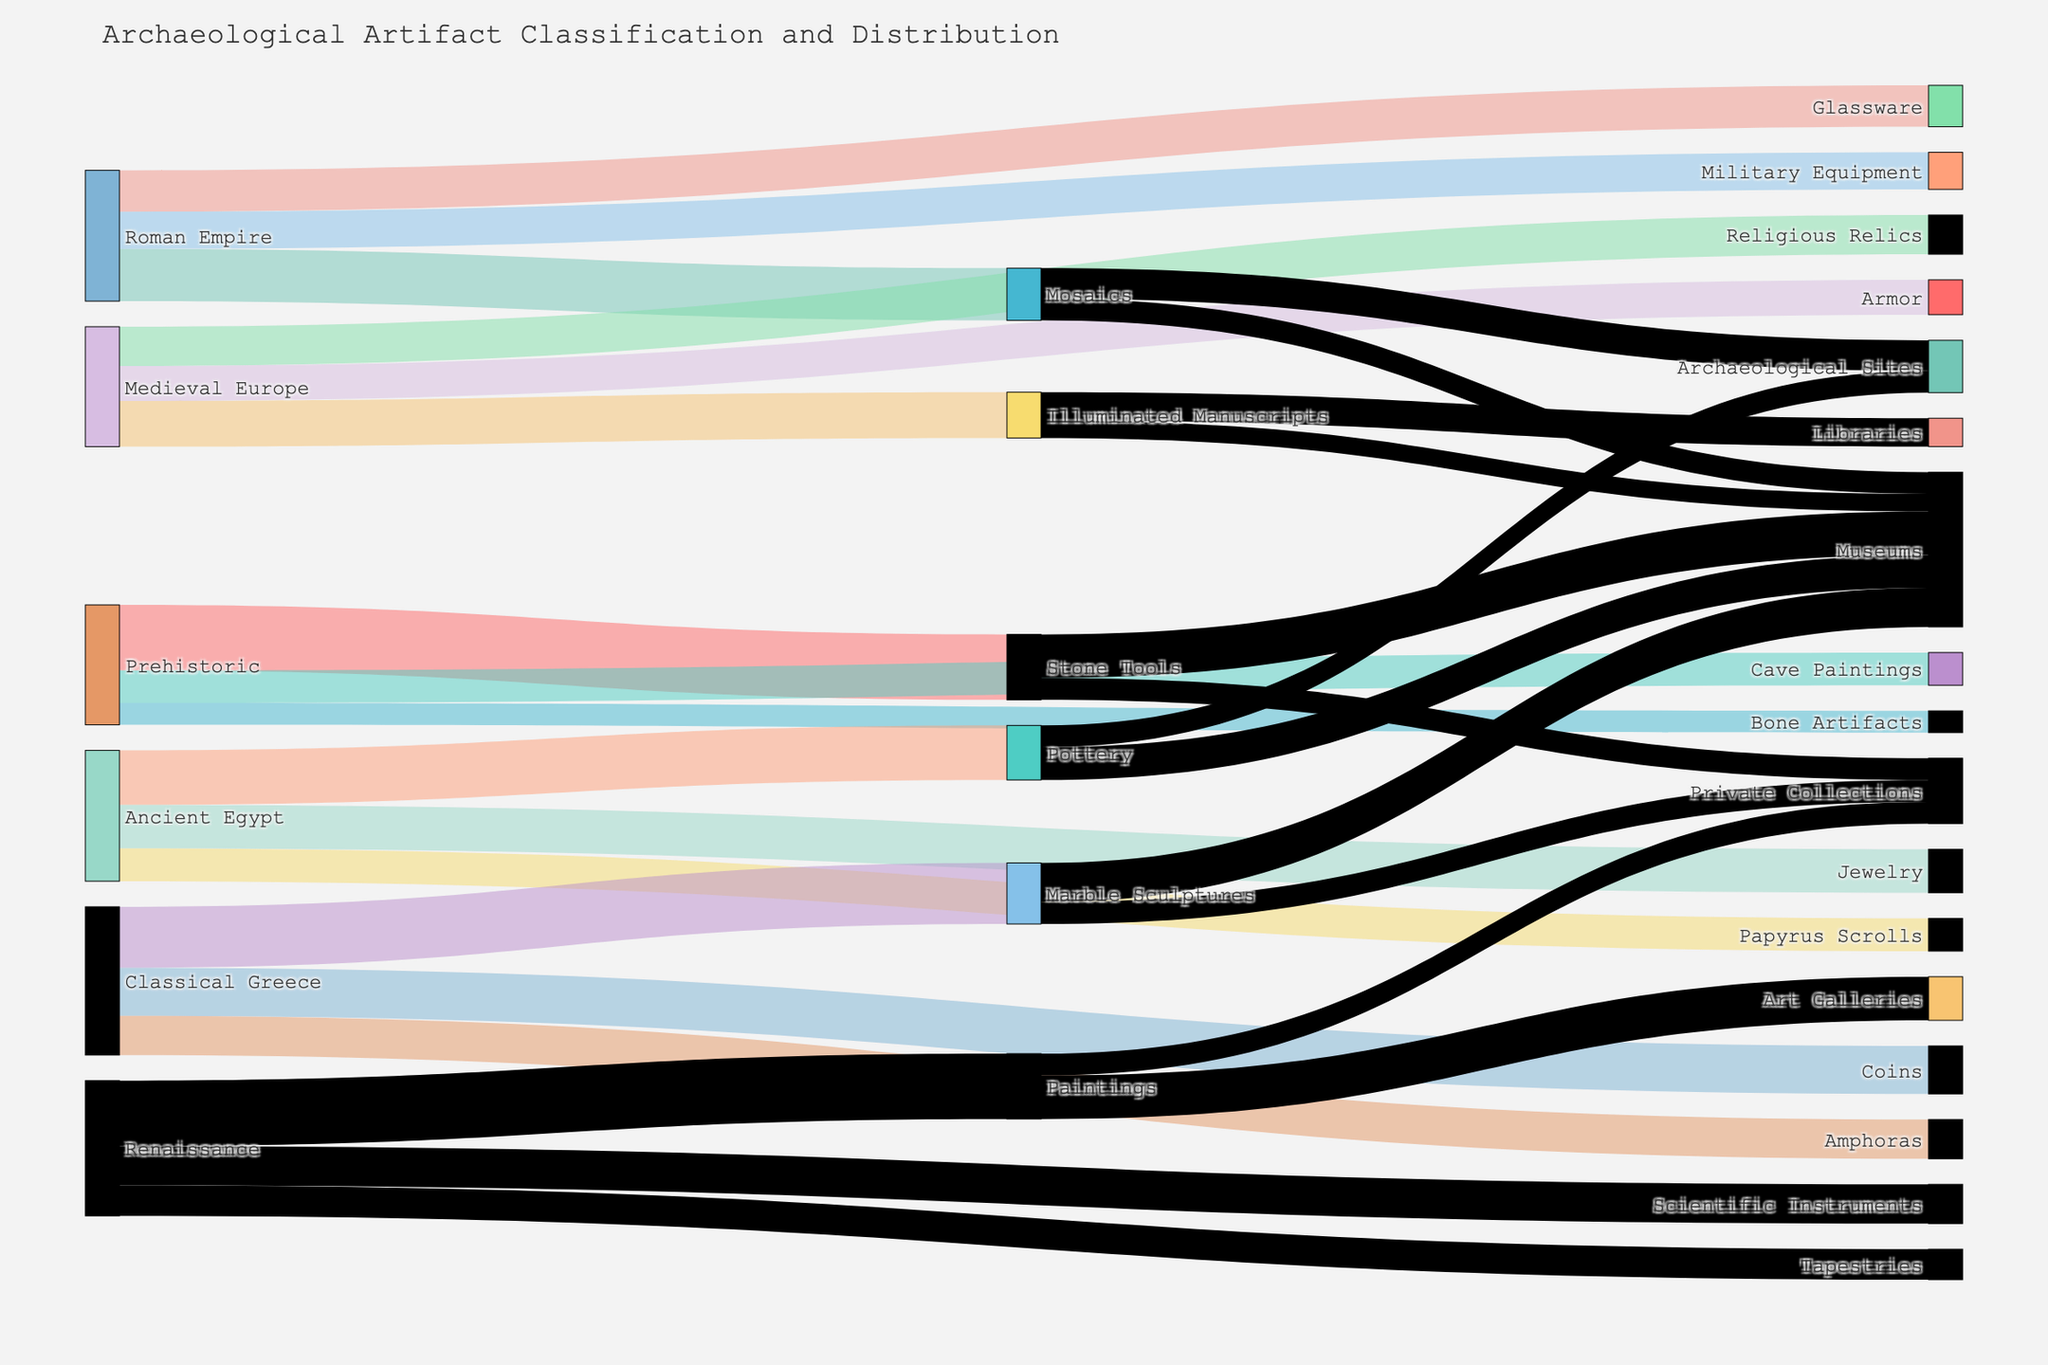What's the title of the figure? The title is usually displayed at the top of the figure, summarizing the content of the visual representation in one line.
Answer: Archaeological Artifact Classification and Distribution Which period has the highest value of artifacts? By inspecting the Sankey diagram, the period with the widest section or multiple flows totaling a large value indicates the highest value.
Answer: Prehistoric How many artifacts from the Renaissance period ended up in Art Galleries? Trace the flow from "Renaissance" to "Paintings" and then to "Art Galleries." The number at the end of the flow to "Art Galleries" represents the count.
Answer: 200 Compare the number of coins from Classical Greece with the number of military equipment from the Roman Empire. Which is greater? Locate the flows originating from "Classical Greece" to "Coins" and "Roman Empire" to "Military Equipment" and compare their values.
Answer: Coins What is the total value of artifacts classified under "Museums"? Sum up all flow values that are directed towards the node "Museums". The values from the different sources should be added together.
Answer: 150 (Pottery) + 180 (Marble Sculptures) + 100 (Mosaics) + 80 (Illuminated Manuscripts) + 200 (Stone Tools) = 710 How does the value of prehistorical Cave Paintings compare to Renaissance Paintings? Locate the flows from "Prehistoric" to "Cave Paintings" and compare their value to the flow from "Renaissance" to "Paintings".
Answer: Renaissance Paintings are higher What type of artifact from Ancient Egypt had the lowest value? Check the flow values from "Ancient Egypt" to its artifacts and identify the smallest number.
Answer: Papyrus Scrolls What is the combined value of artifacts in Private Collections from all periods? Find the flows to "Private Collections" from various artifacts across periods and sum their values.
Answer: 100 (Stone Tools) + 100 (Marble Sculptures) + 100 (Paintings) = 300 Which medium has more artifacts flowing into it, Museums or Archaeological Sites? Sum the flows going to "Museums" and compare it to the sum of the flows going to "Archaeological Sites".
Answer: Museums What's the difference between the value of Scientific Instruments from the Renaissance and Armor from Medieval Europe? Subtract the value of the flow from "Medieval Europe" to "Armor" from the flow from "Renaissance" to "Scientific Instruments".
Answer: 180 - 160 = 20 